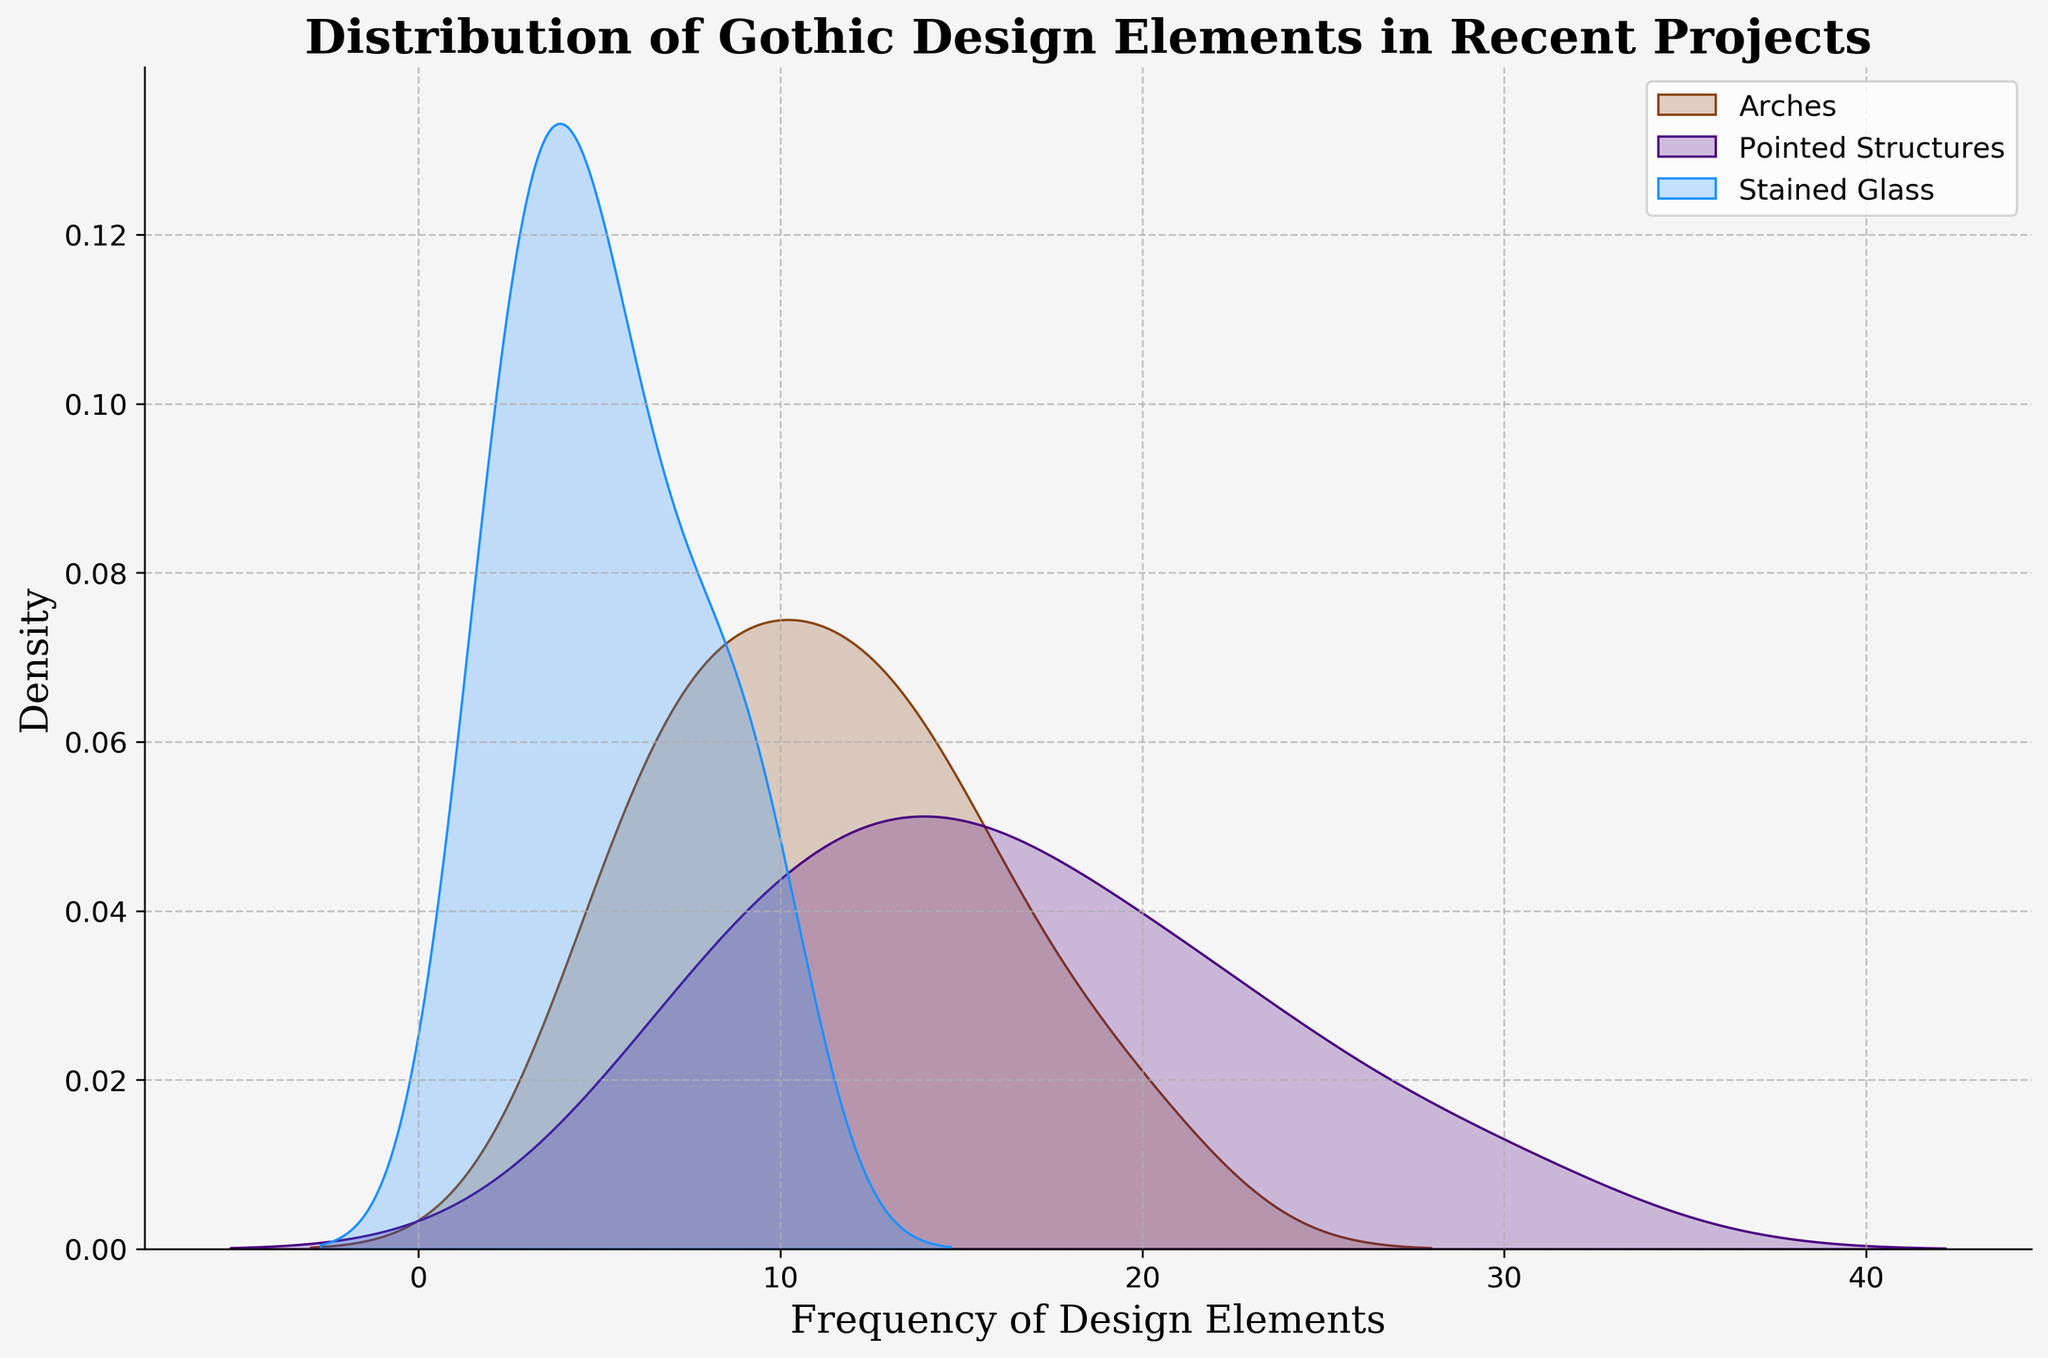What is the title of the plot? The title is located at the top of the plot and is usually in larger font size, making it easy to spot.
Answer: Distribution of Gothic Design Elements in Recent Projects Which color represents the frequency distribution of pointed structures? In the legend, each design element is associated with a color. The color for pointed structures is labeled.
Answer: Indigo What is the color assigned to stained glass in the distribution plot? The legend at the upper right of the plot matches design elements to their respective colors.
Answer: Blue How many types of design elements are represented in the plot? The legend next to the plot lists the design elements being represented.
Answer: Three Which design element appears to have the highest density peak? Observing the plot, the line with the highest peak indicates the design element with the highest density.
Answer: Pointed Structures What is the approximate peak frequency value for arches? Look at where the density line for arches reaches its highest point on the x-axis.
Answer: Around 15 How does the density of pointed structures compare to arches at their peaks? Compare the highest density points of both distributions. The pointed structures line should be higher if it's denser.
Answer: Pointed structures have a higher peak density than arches Is the distribution of stained glass elements broader or narrower compared to the other elements? Observe the spread of the density line for stained glass. A broader distribution will span more of the x-axis.
Answer: Broader Which design element has the smallest variation in frequency distribution? The design with the narrowest and sharpest peak indicates the smallest variation.
Answer: Arches At approximately what frequency do all three design elements intersect? Look for the x-axis value where all three density lines appear to overlap.
Answer: Around frequency 10 